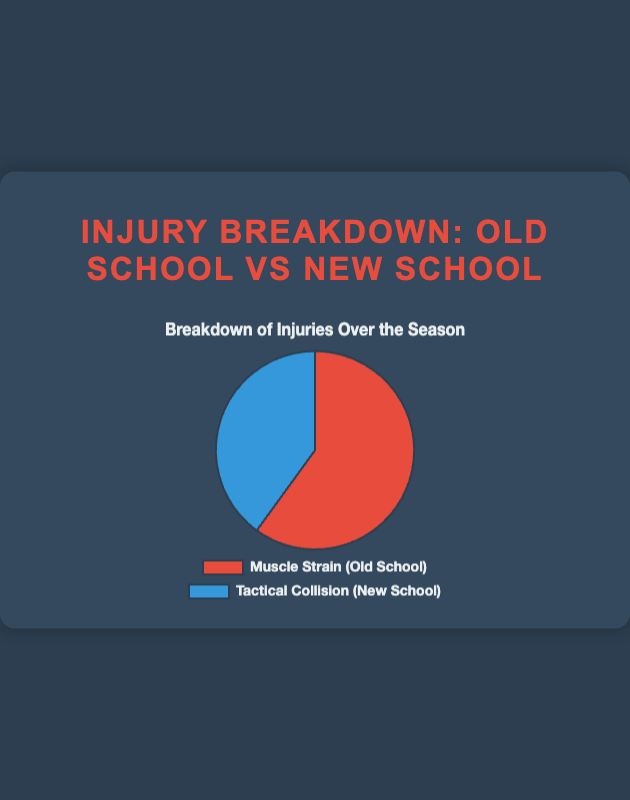What percentage of injuries are due to muscle strain? First, we note the total number of injuries: Muscle Strain (120) + Tactical Collision (80) = 200. The percentage of muscle strain injuries is (120 / 200) * 100 = 60%.
Answer: 60% How many more injuries are from muscle strain compared to tactical collisions? Muscle strain injuries are 120, and tactical collision injuries are 80. The difference is 120 - 80 = 40.
Answer: 40 Which type of injury is most common? By looking at the pie chart, the section representing muscle strain is larger than the one for tactical collisions. Therefore, muscle strain injuries are more common.
Answer: Muscle strain What is the ratio of muscle strain injuries to tactical collision injuries? Muscle strain injuries are 120, and tactical collision injuries are 80. The ratio is 120:80, which simplifies to 3:2.
Answer: 3:2 What fraction of the total injuries are tactical collisions? The total number of injuries is 200. Tactical collisions account for 80 of these. The fraction is 80 / 200 = 2 / 5.
Answer: 2/5 How would the pie chart change if there were 50 more tactical collision injuries? Adding 50 more tactical collision injuries means the new count is 80 + 50 = 130. The new total number of injuries is 120 (muscle strain) + 130 (tactical collision) = 250. The muscle strain injuries fraction would be 120 / 250 = 48%, and the tactical collision fraction would be 130 / 250 = 52%.
Answer: Tactical collisions would become more frequent, leading to a larger blue section and slightly smaller red section What is the combined total of muscle strain and tactical collision injuries? Adding the two injury types together: 120 (muscle strain) + 80 (tactical collision) = 200.
Answer: 200 What part of the pie chart corresponds to tactical collision injuries? By color and label, the section representing tactical collision injuries is blue.
Answer: Blue By what factor do muscle strain injuries exceed tactical collision injuries? Muscle strain injuries are 120, and tactical collision injuries are 80. Dividing the former by the latter, 120 / 80 = 1.5.
Answer: 1.5 If the total number of injuries were evenly distributed, what would be the injury count for each type? The total number of injuries is 200. If evenly distributed, each type would have 200 / 2 = 100 injuries.
Answer: 100 